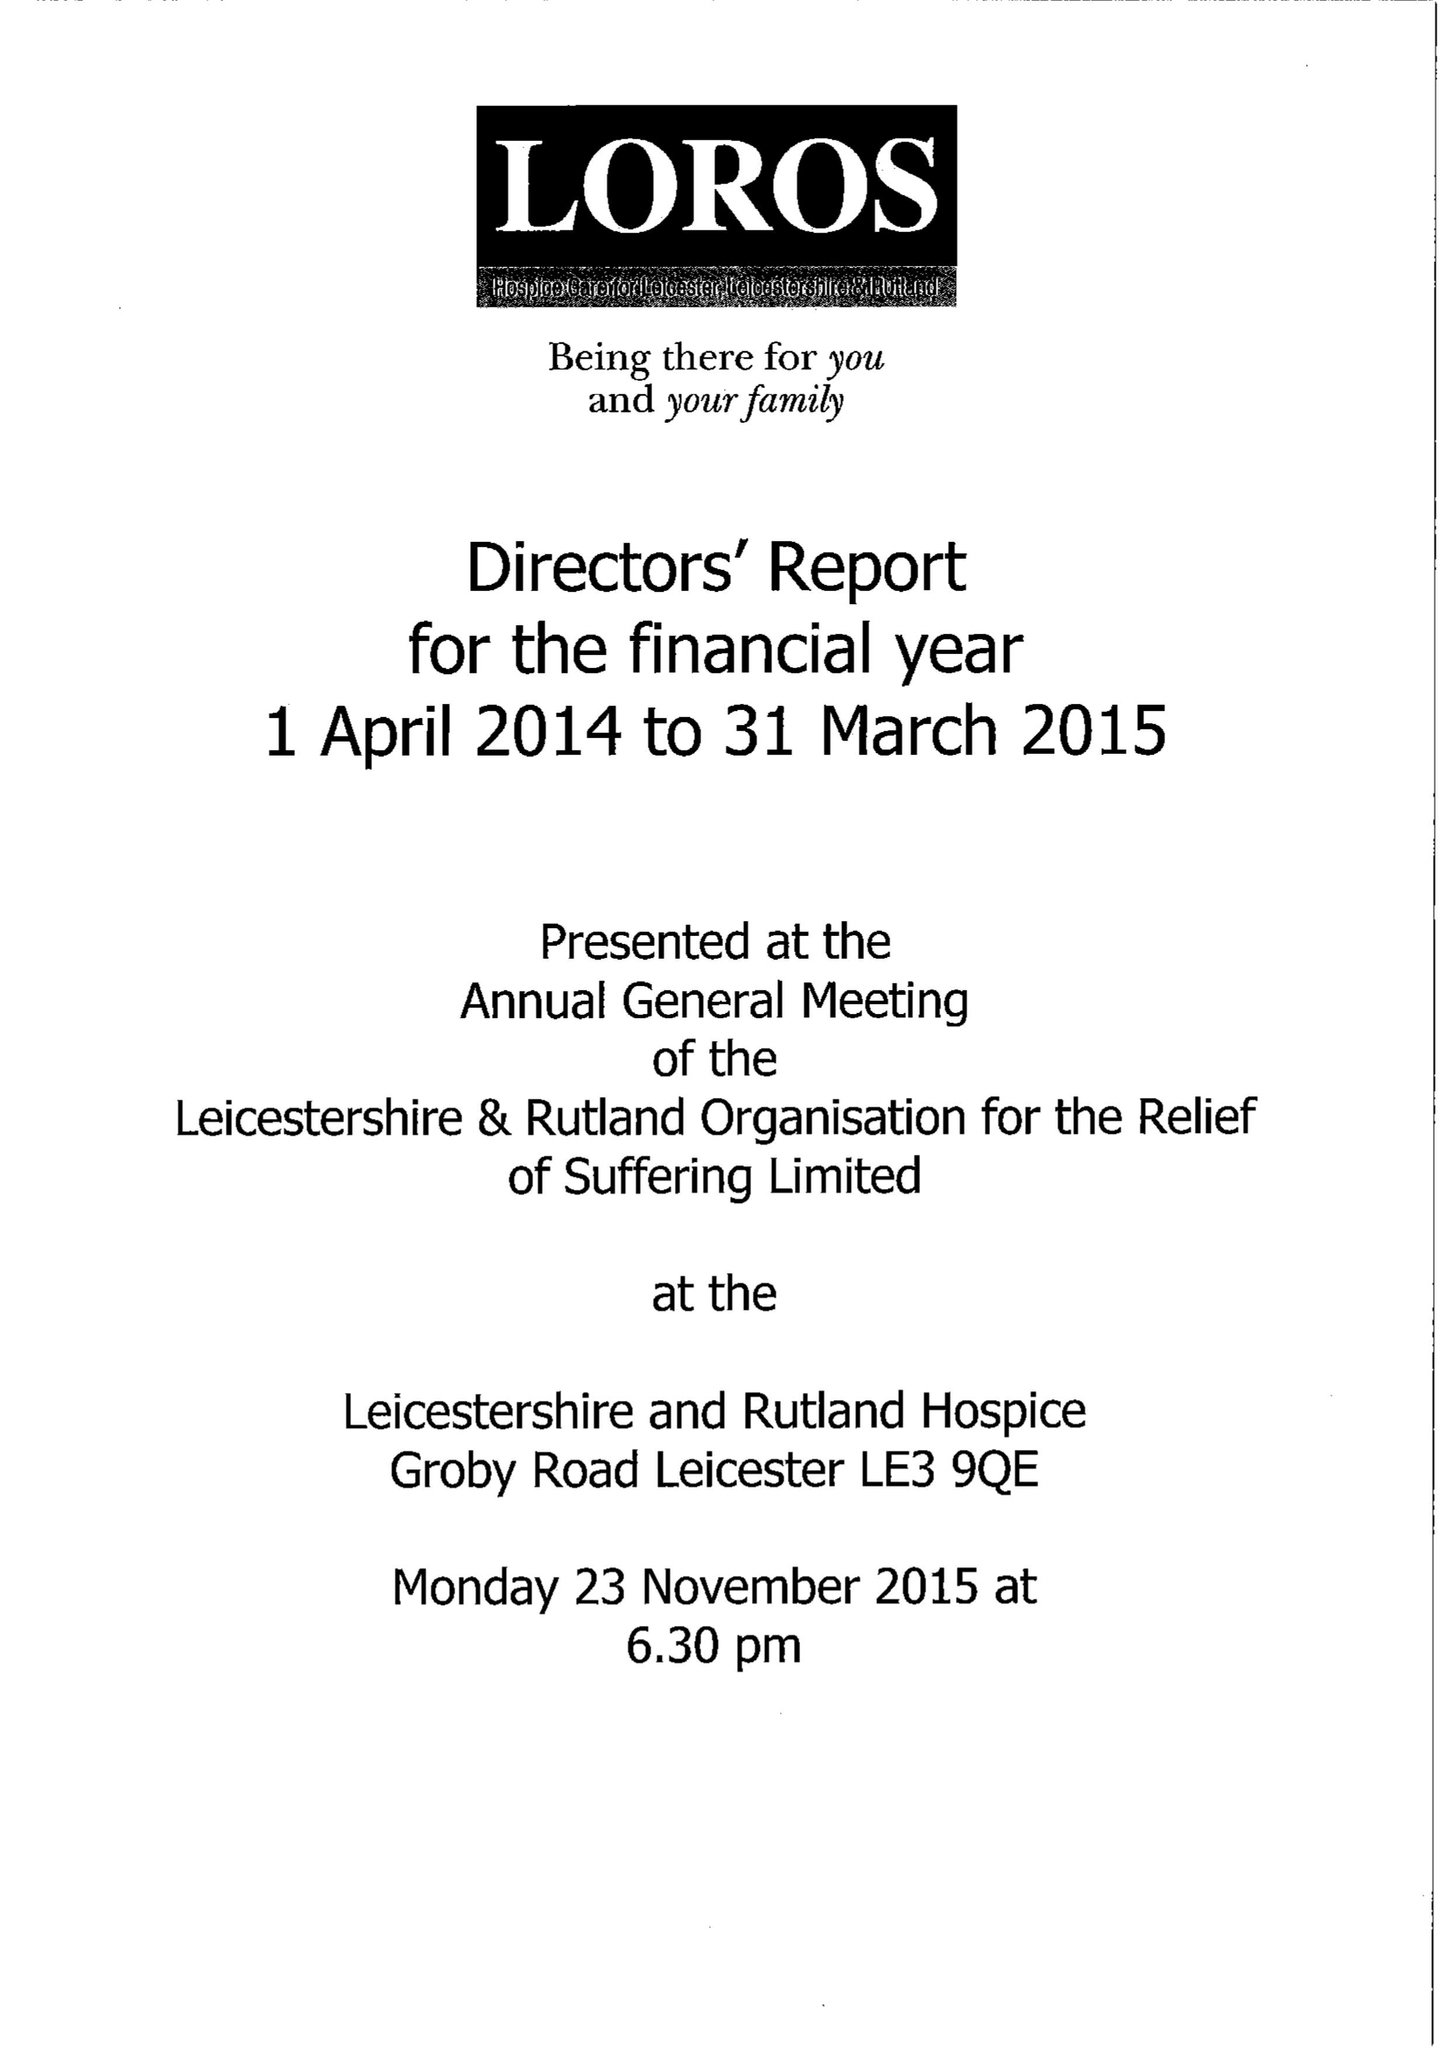What is the value for the address__street_line?
Answer the question using a single word or phrase. GROBY ROAD 